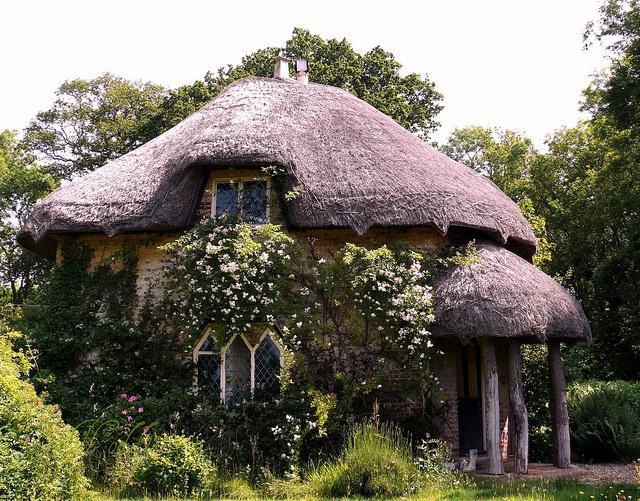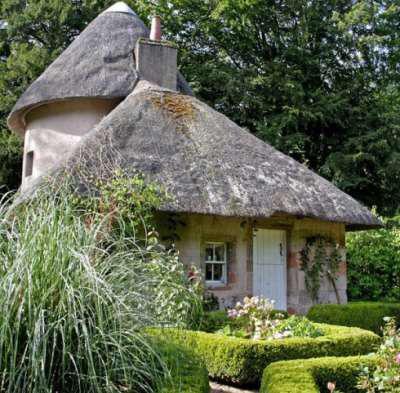The first image is the image on the left, the second image is the image on the right. For the images displayed, is the sentence "There is a cone shaped roof." factually correct? Answer yes or no. Yes. 